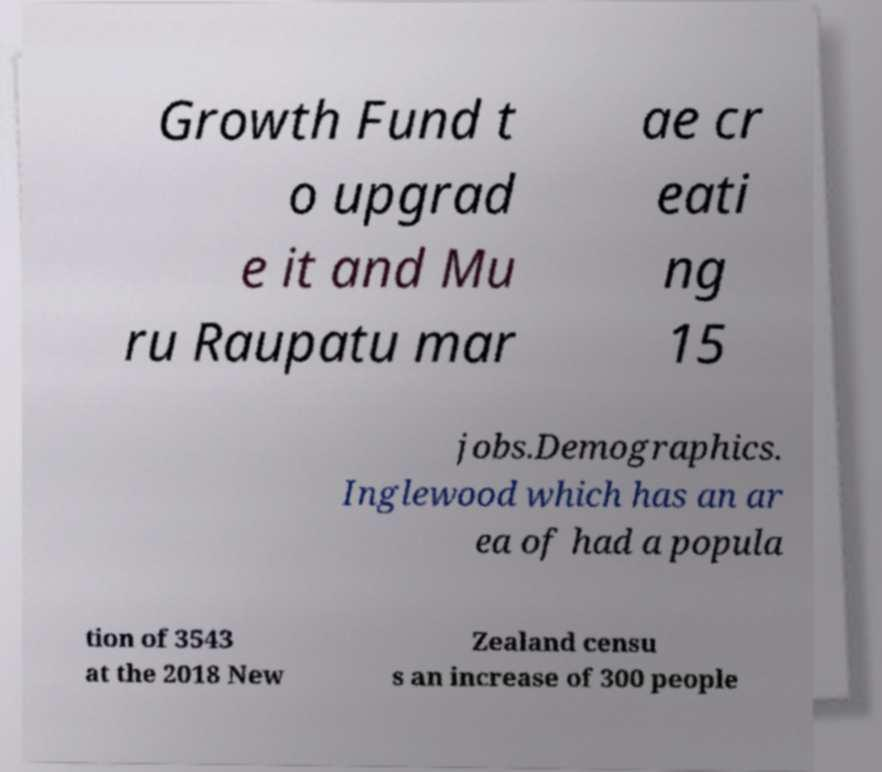Please read and relay the text visible in this image. What does it say? Growth Fund t o upgrad e it and Mu ru Raupatu mar ae cr eati ng 15 jobs.Demographics. Inglewood which has an ar ea of had a popula tion of 3543 at the 2018 New Zealand censu s an increase of 300 people 